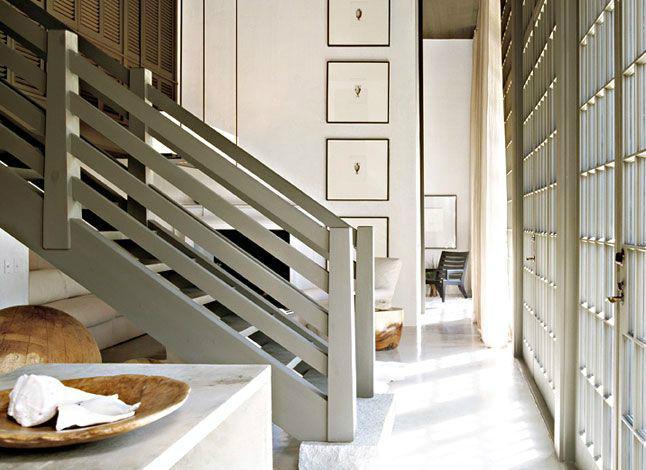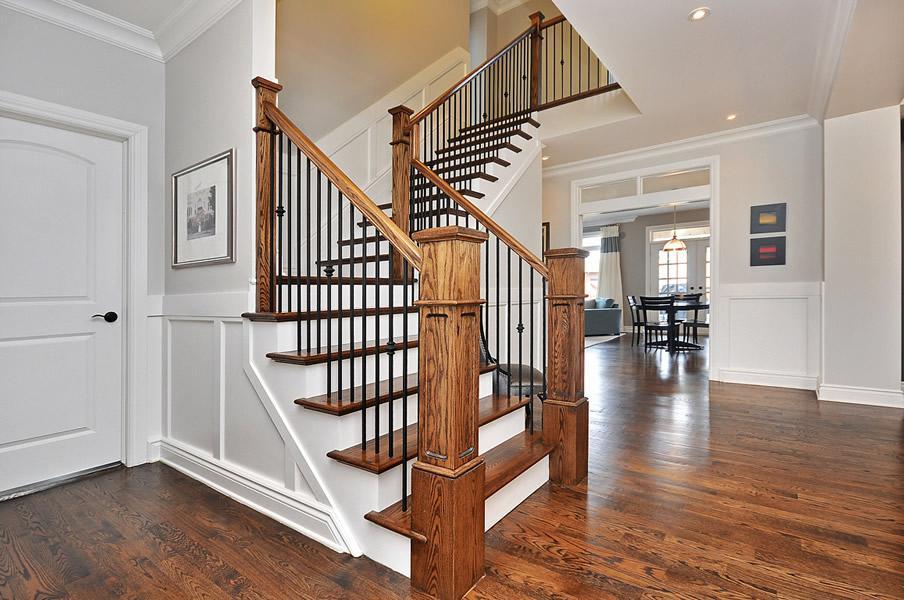The first image is the image on the left, the second image is the image on the right. Analyze the images presented: Is the assertion "There are 6 stairs point forward right with wooden rail and multiple black metal rods." valid? Answer yes or no. Yes. The first image is the image on the left, the second image is the image on the right. Given the left and right images, does the statement "At least one of the lights is a pendant-style light hanging from the ceiling." hold true? Answer yes or no. No. 